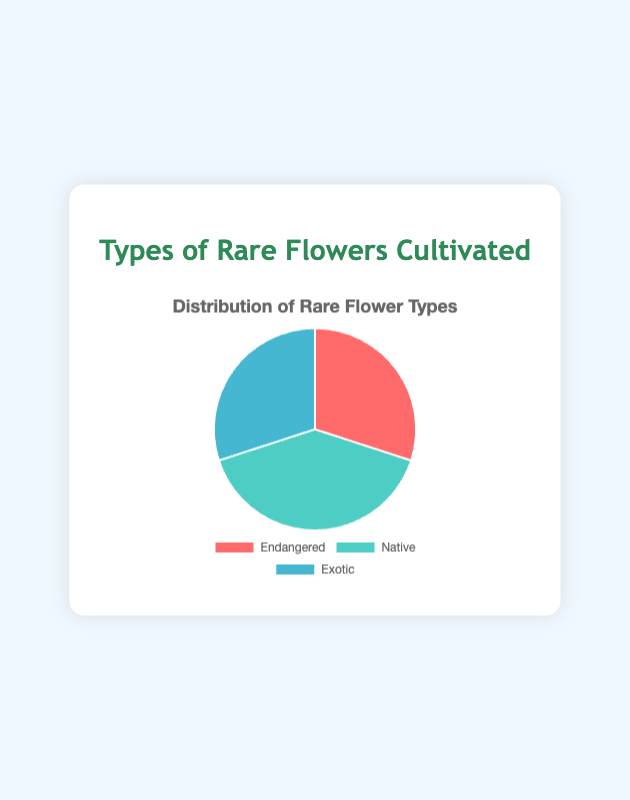Which type of rare flower has the largest number of species cultivated? The pie chart shows that the "Native" section has the largest portion.
Answer: Native What is the total number of rare flower species cultivated? Add the numbers of all three categories: Endangered (30) + Native (40) + Exotic (30) = 100.
Answer: 100 What proportion of the total number of species cultivated are Exotic flowers? The total number is 100 species. Exotic flowers are 30 out of 100. So, the proportion is 30/100 = 0.30 or 30%.
Answer: 30% How does the number of Endangered species compare to Native species? Endangered has 30 species and Native has 40 species. 40 is greater than 30.
Answer: Native has more species If 5 more Endangered species were added, what would be their new percentage of the total species? Adding 5 to the Endangered category gives 35 species. The new total is 100 + 5 = 105. The percentage is (35/105) * 100 = 33.33%.
Answer: 33.33% What colors represent the Native flower species on the chart? The pie chart uses a distinct color for each category. The Native section is represented by green.
Answer: Green Which two categories have an equal number of rare flower species? The Endangered and Exotic categories both have 30 species each, as shown on the pie chart.
Answer: Endangered and Exotic What is the difference in the number of species between the type with the most species and the type with the least species? Native has 40 species (most) and both Endangered and Exotic have 30 (least). The difference is 40 - 30 = 10 species.
Answer: 10 species What percentage of the total species are either Endangered or Exotic? Endangered and Exotic combined have 30 + 30 = 60 species. The percentage is (60/100) * 100 = 60%.
Answer: 60% What is the average number of rare flower species cultivated in each category? The total number of species is 100, and there are 3 categories. The average is 100 / 3 ≈ 33.33 species per category.
Answer: 33.33 species 